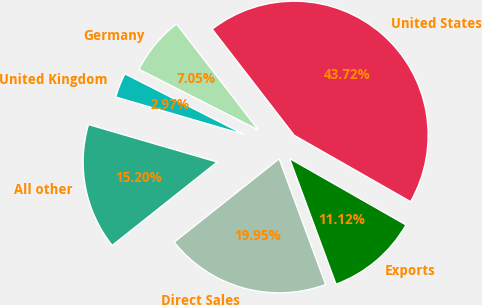<chart> <loc_0><loc_0><loc_500><loc_500><pie_chart><fcel>United States<fcel>Germany<fcel>United Kingdom<fcel>All other<fcel>Direct Sales<fcel>Exports<nl><fcel>43.72%<fcel>7.05%<fcel>2.97%<fcel>15.2%<fcel>19.95%<fcel>11.12%<nl></chart> 